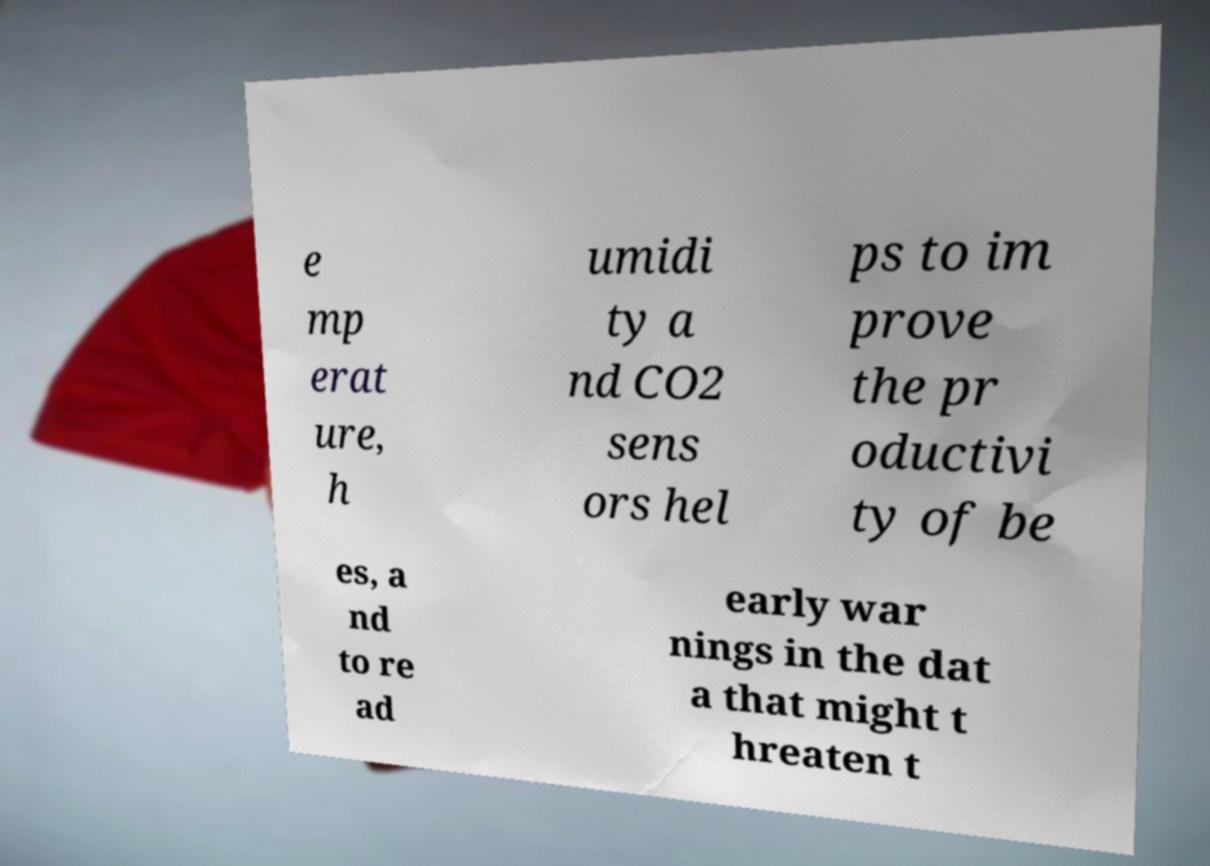For documentation purposes, I need the text within this image transcribed. Could you provide that? e mp erat ure, h umidi ty a nd CO2 sens ors hel ps to im prove the pr oductivi ty of be es, a nd to re ad early war nings in the dat a that might t hreaten t 